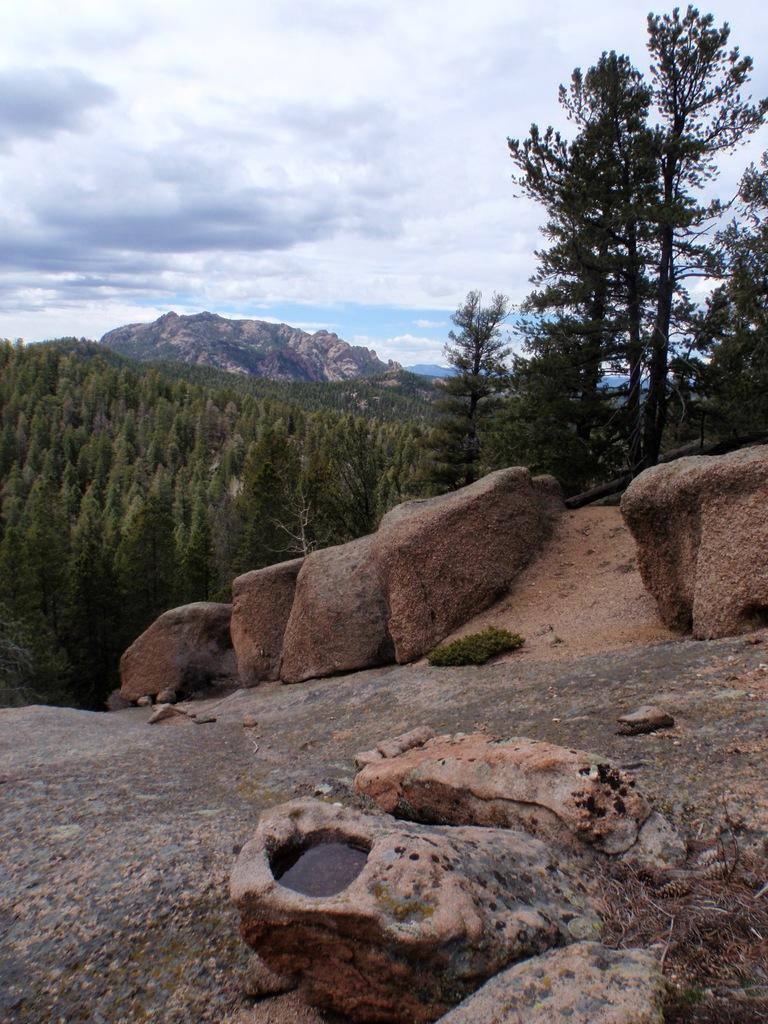What type of vegetation can be seen in the image? There are trees in the image. What geographical feature is present in the image? There is a hill in the image. How would you describe the sky in the image? The sky is cloudy in the image. What type of natural formation can be seen in the image? There are rocks visible in the image. Where is the stone located in the image? There is no stone mentioned or visible in the image. What type of picture is hanging on the hill in the image? There is no picture mentioned or visible in the image. 